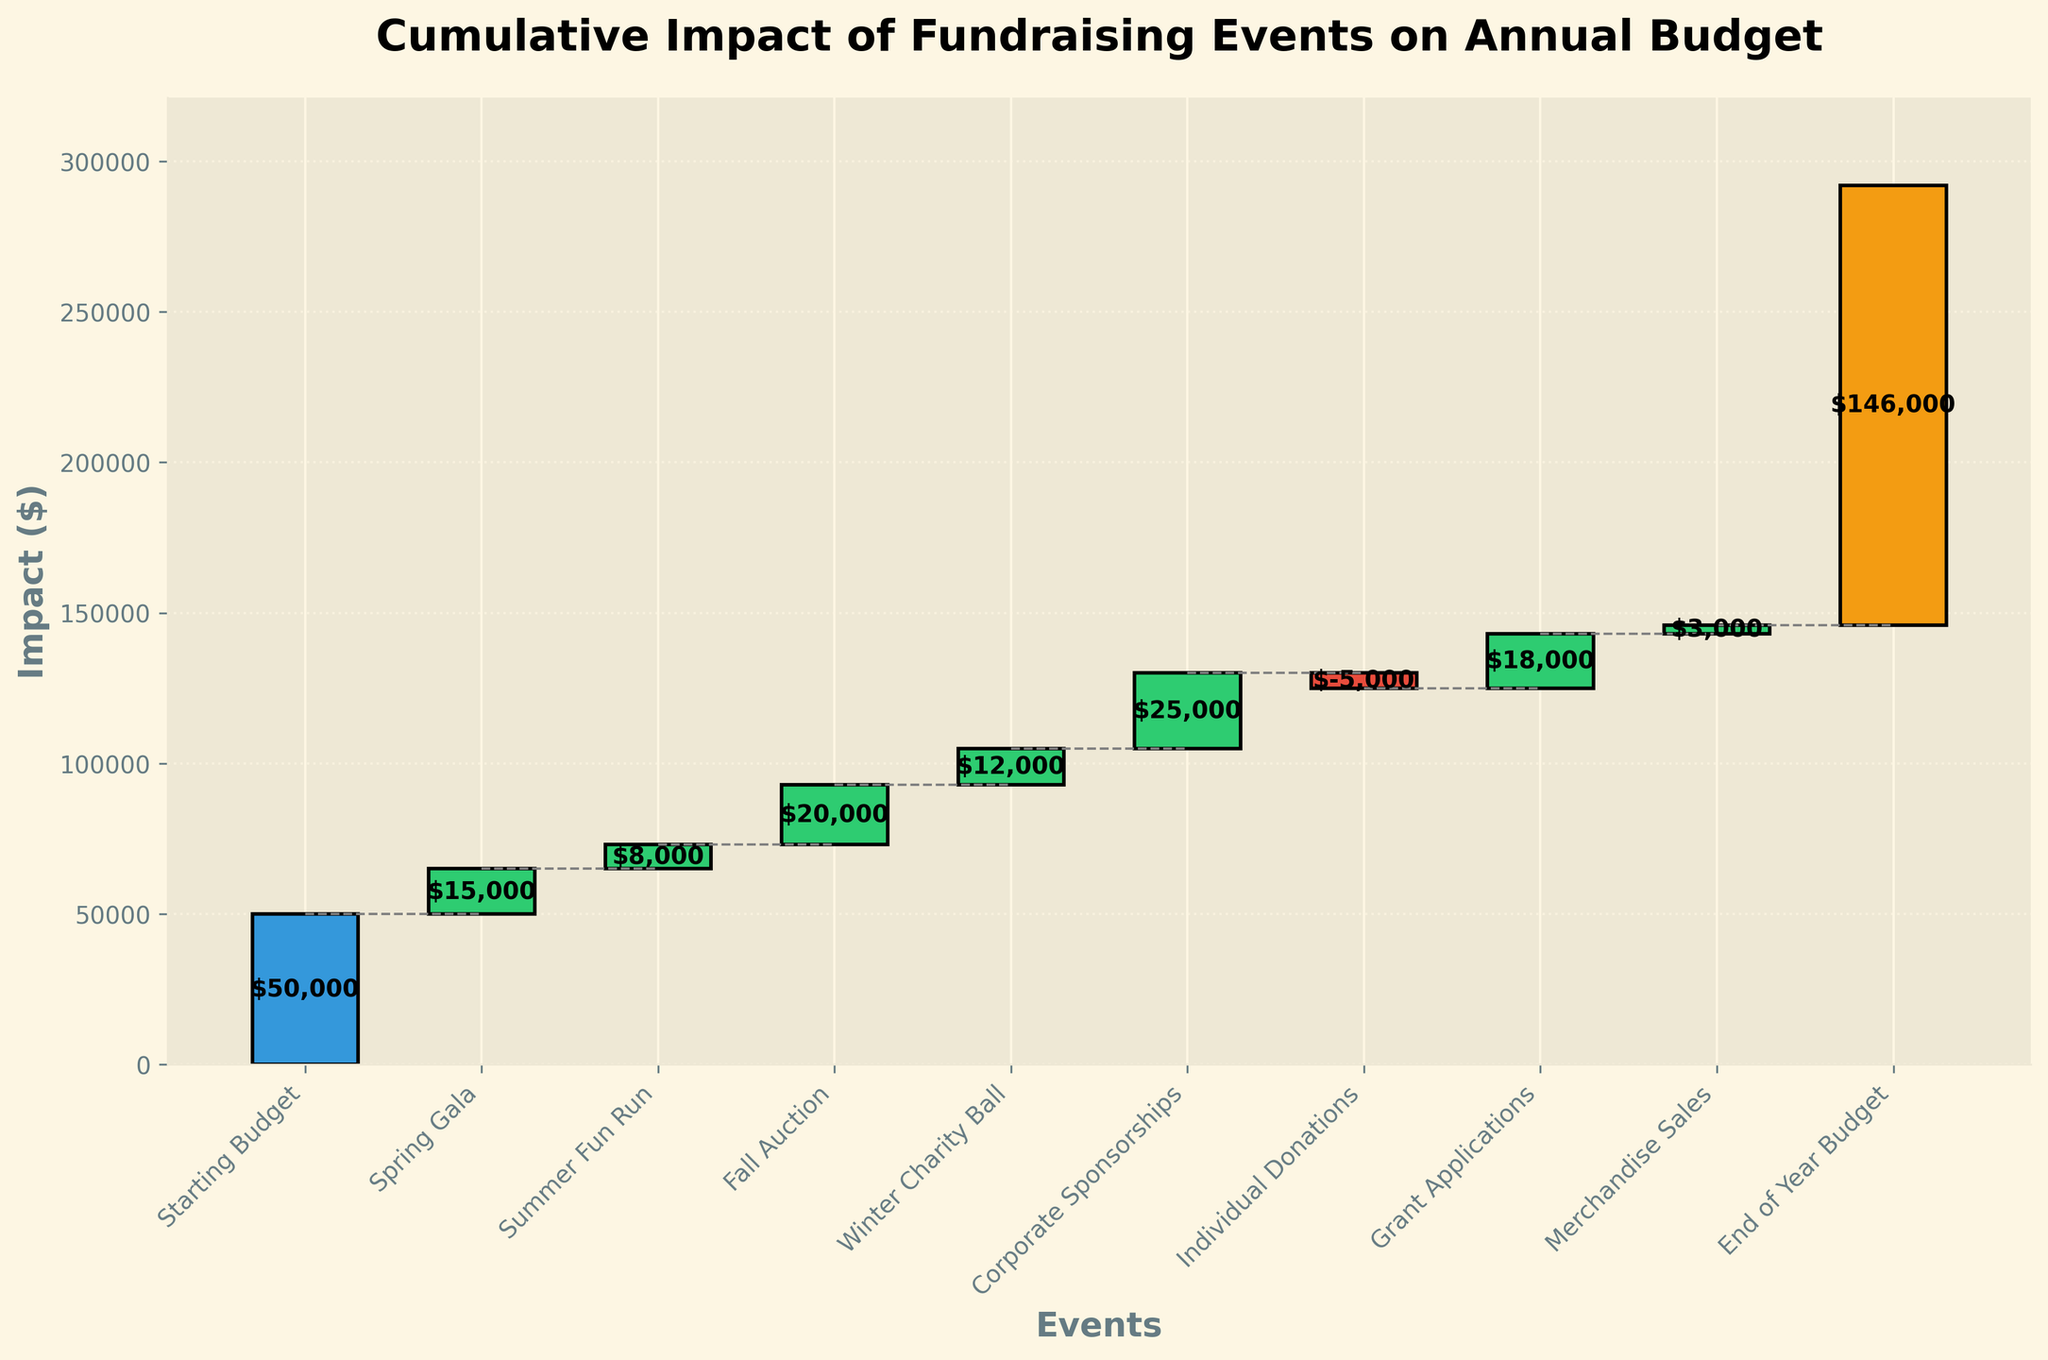What is the title of the chart? The title is the heading text that is large and bold on top of the chart. It gives us a summary of what the chart is about.
Answer: Cumulative Impact of Fundraising Events on Annual Budget What color is used to represent the Starting Budget bar? The color used for the Starting Budget bar is distinct and different from other bars to clearly set it apart. By looking at the color of the first bar, it is blue.
Answer: Blue Which event had the largest positive impact on the budget? To find the event with the largest positive impact, look at the lengths of the green bars since they represent positive impacts. The Fall Auction has the tallest green bar.
Answer: Fall Auction How much was the impact of Individual Donations on the budget? The impact of Individual Donations can be read directly from its bar label or the height of the bar itself, noting that it is a negative impact as it's colored differently (red).
Answer: -$5,000 What is the final budget at the end of the year? The End of Year Budget is represented by the last bar. The value indicated at the top of the bar shows the final budget.
Answer: $146,000 What is the cumulative impact after the Spring Gala? After the Spring Gala, the cumulative impact is the sum of the Starting Budget and the first event's impact.
Answer: $65,000 Which event contributed more to the budget, Winter Charity Ball or Grant Applications? Compare the bars of Winter Charity Ball and Grant Applications to see which one is taller. Grant Applications has a taller bar which implies a larger contribution.
Answer: Grant Applications How much did Corporate Sponsorships add to the budget relative to Merchandise Sales? Subtract the impact of Merchandise Sales from Corporate Sponsorships to find the relative addition.
Answer: $22,000 Which events have a negative impact on the budget? Look for bars colored red as these indicate negative impacts on the budget. Only Individual Donations has a negative impact.
Answer: Individual Donations What is the cumulative impact before Individual Donations? To find this, sum up all the impacts from the starting budget to just before Individual Donations. This includes Starting Budget, Spring Gala, Summer Fun Run, Fall Auction, Winter Charity Ball, and Corporate Sponsorships
Answer: $108,000 